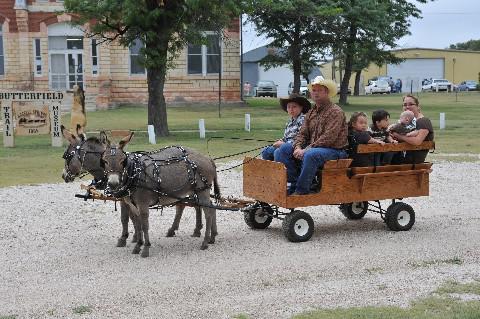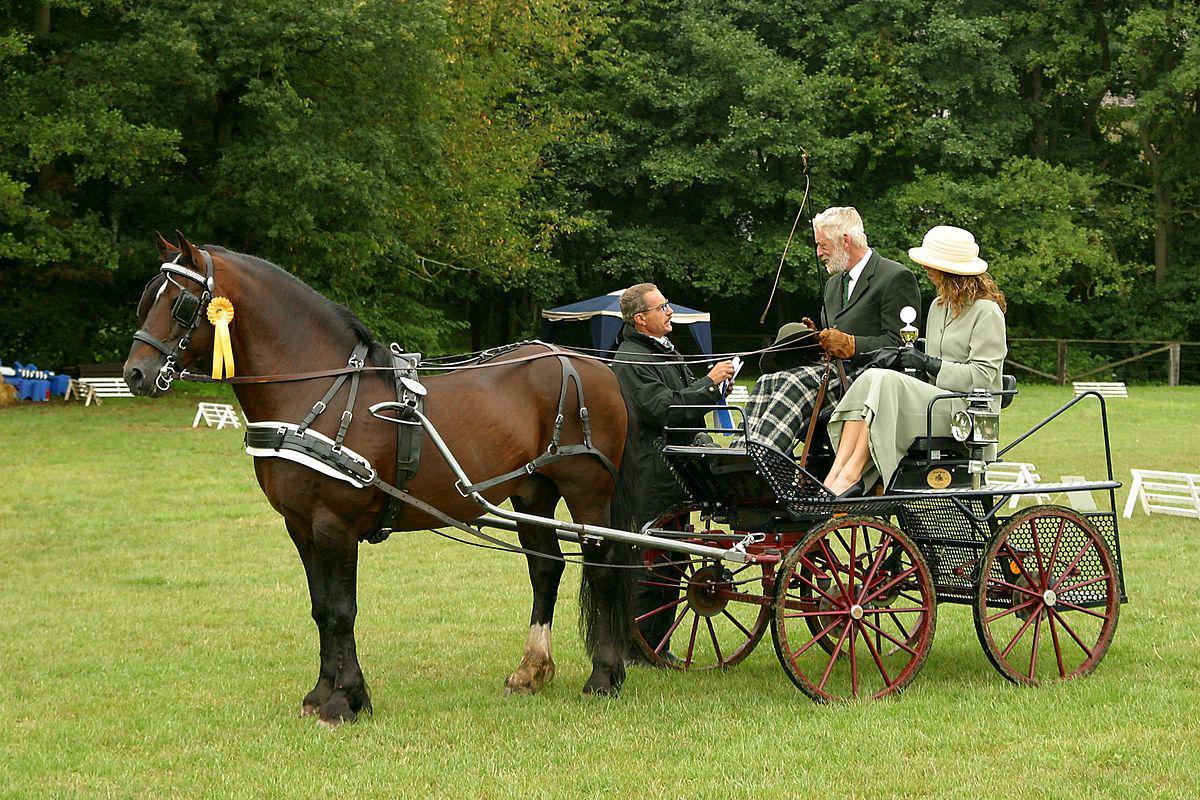The first image is the image on the left, the second image is the image on the right. For the images shown, is this caption "there is exactly one person in the image on the right." true? Answer yes or no. No. 